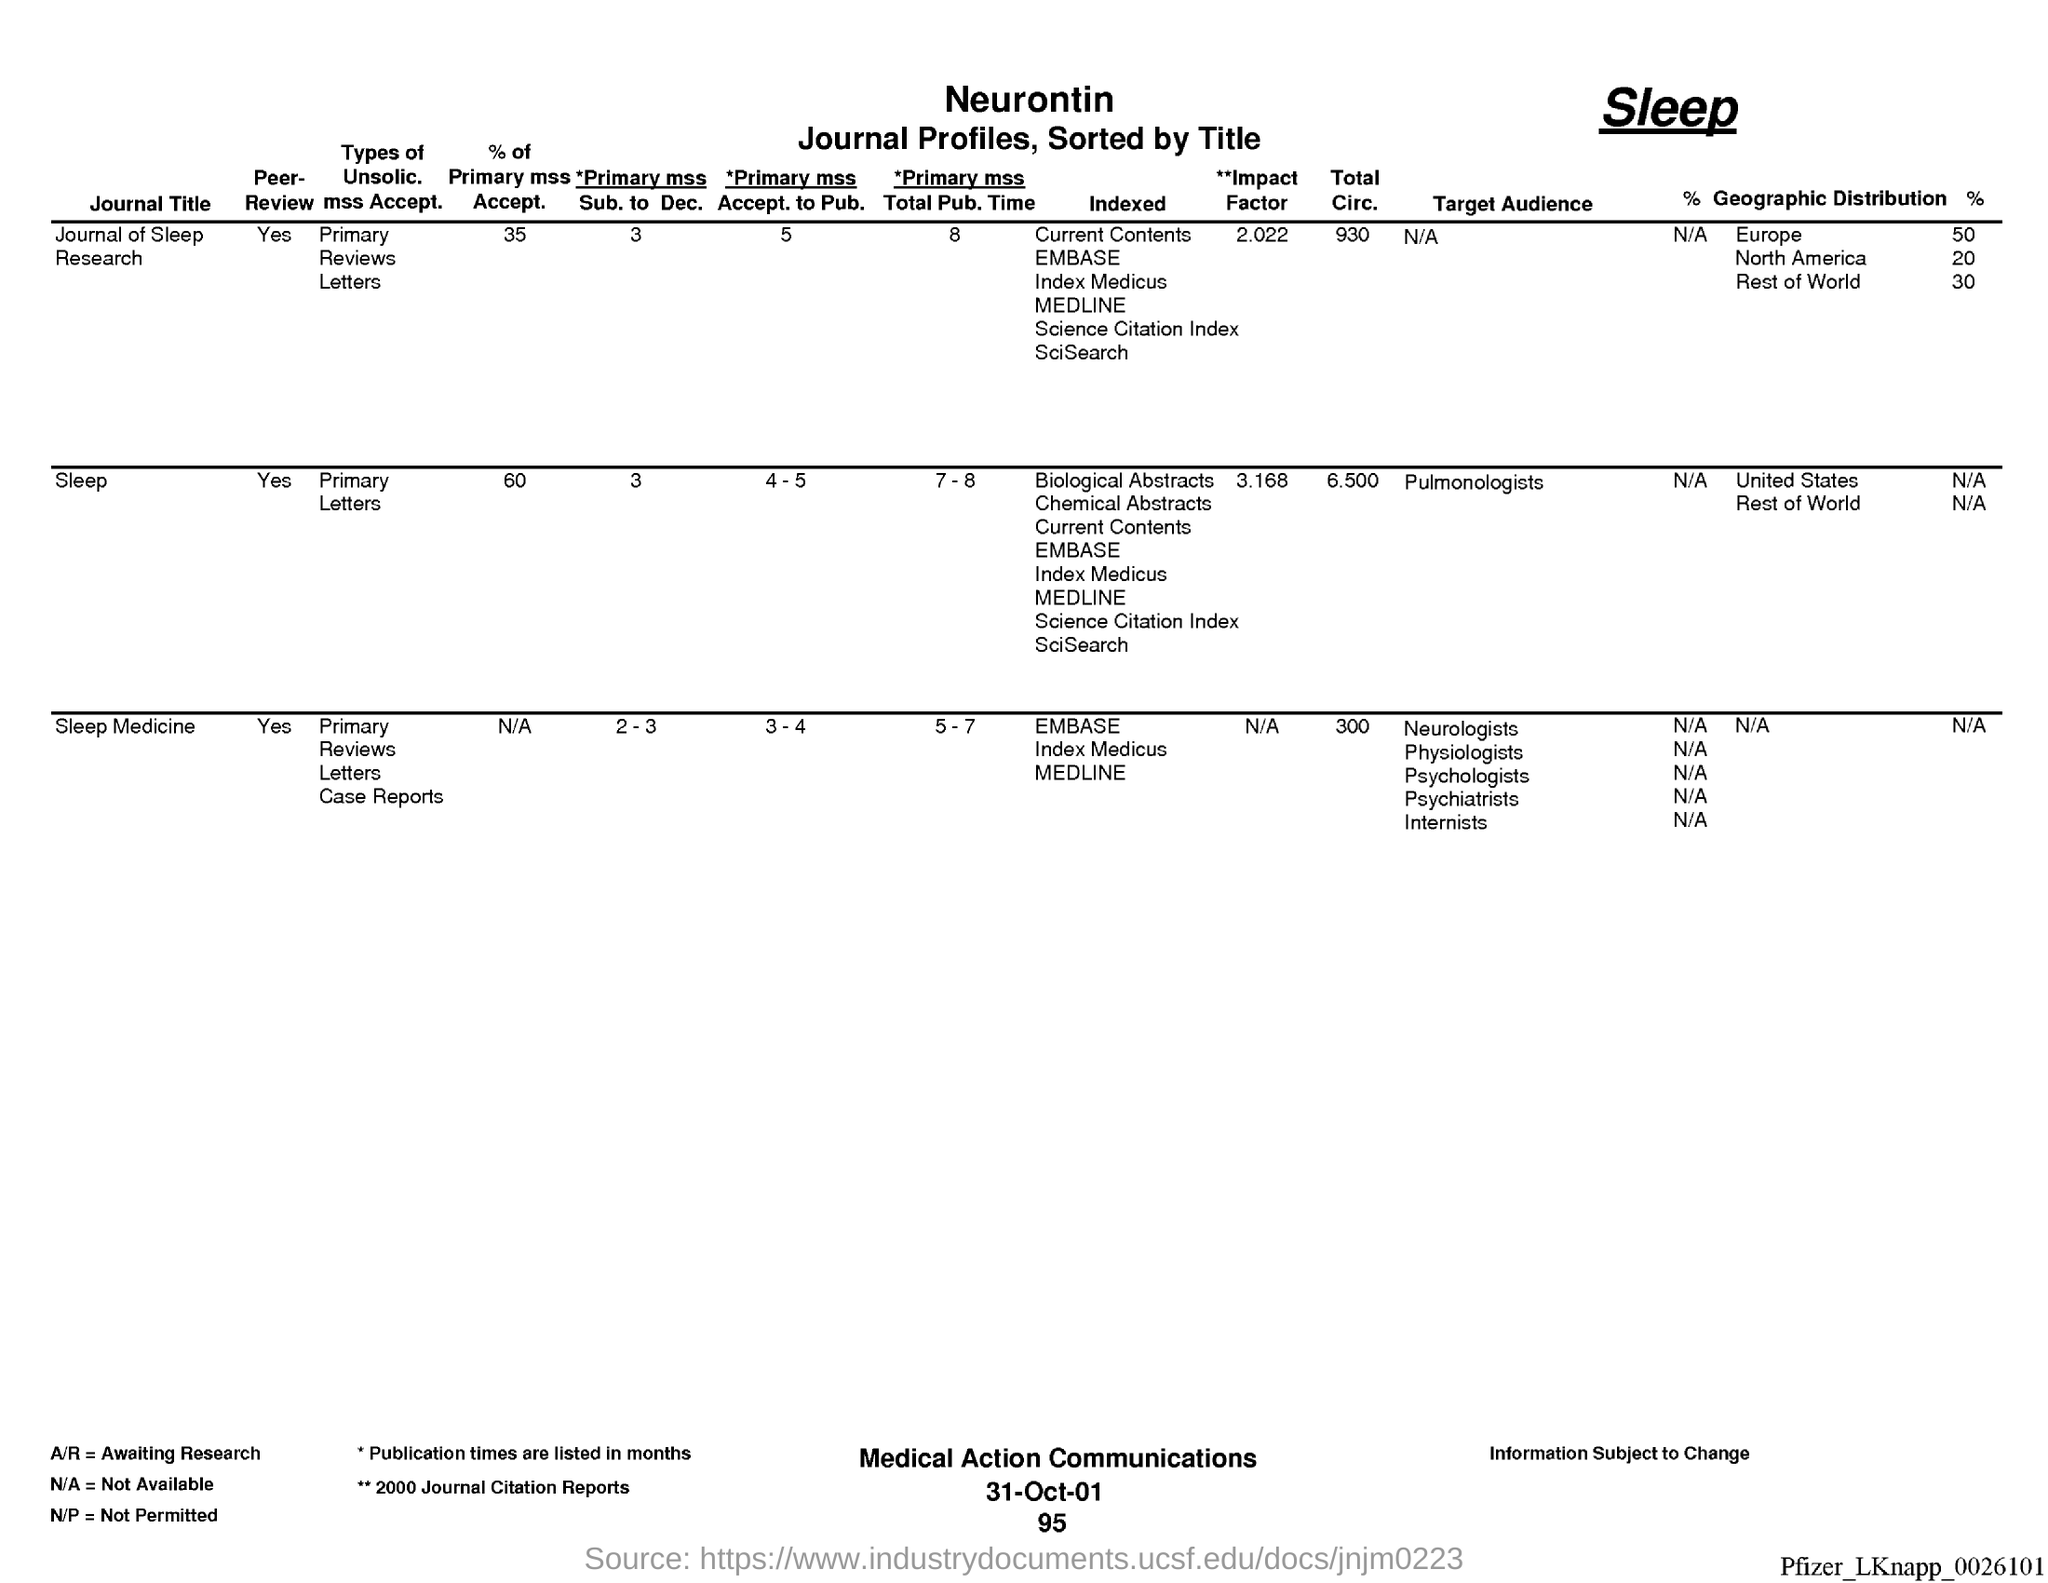List a handful of essential elements in this visual. The primary measure of sleep medicine is typically the sub-question score of 2-3. The date on the document is October 31st, 2001. The primary mss acceptance for sleep is 60%. The primary manuscript subtype for the Journal of Sleep Research is research articles. The primary MSS acceptance for publication in sleep medicine is 3 to 4. 